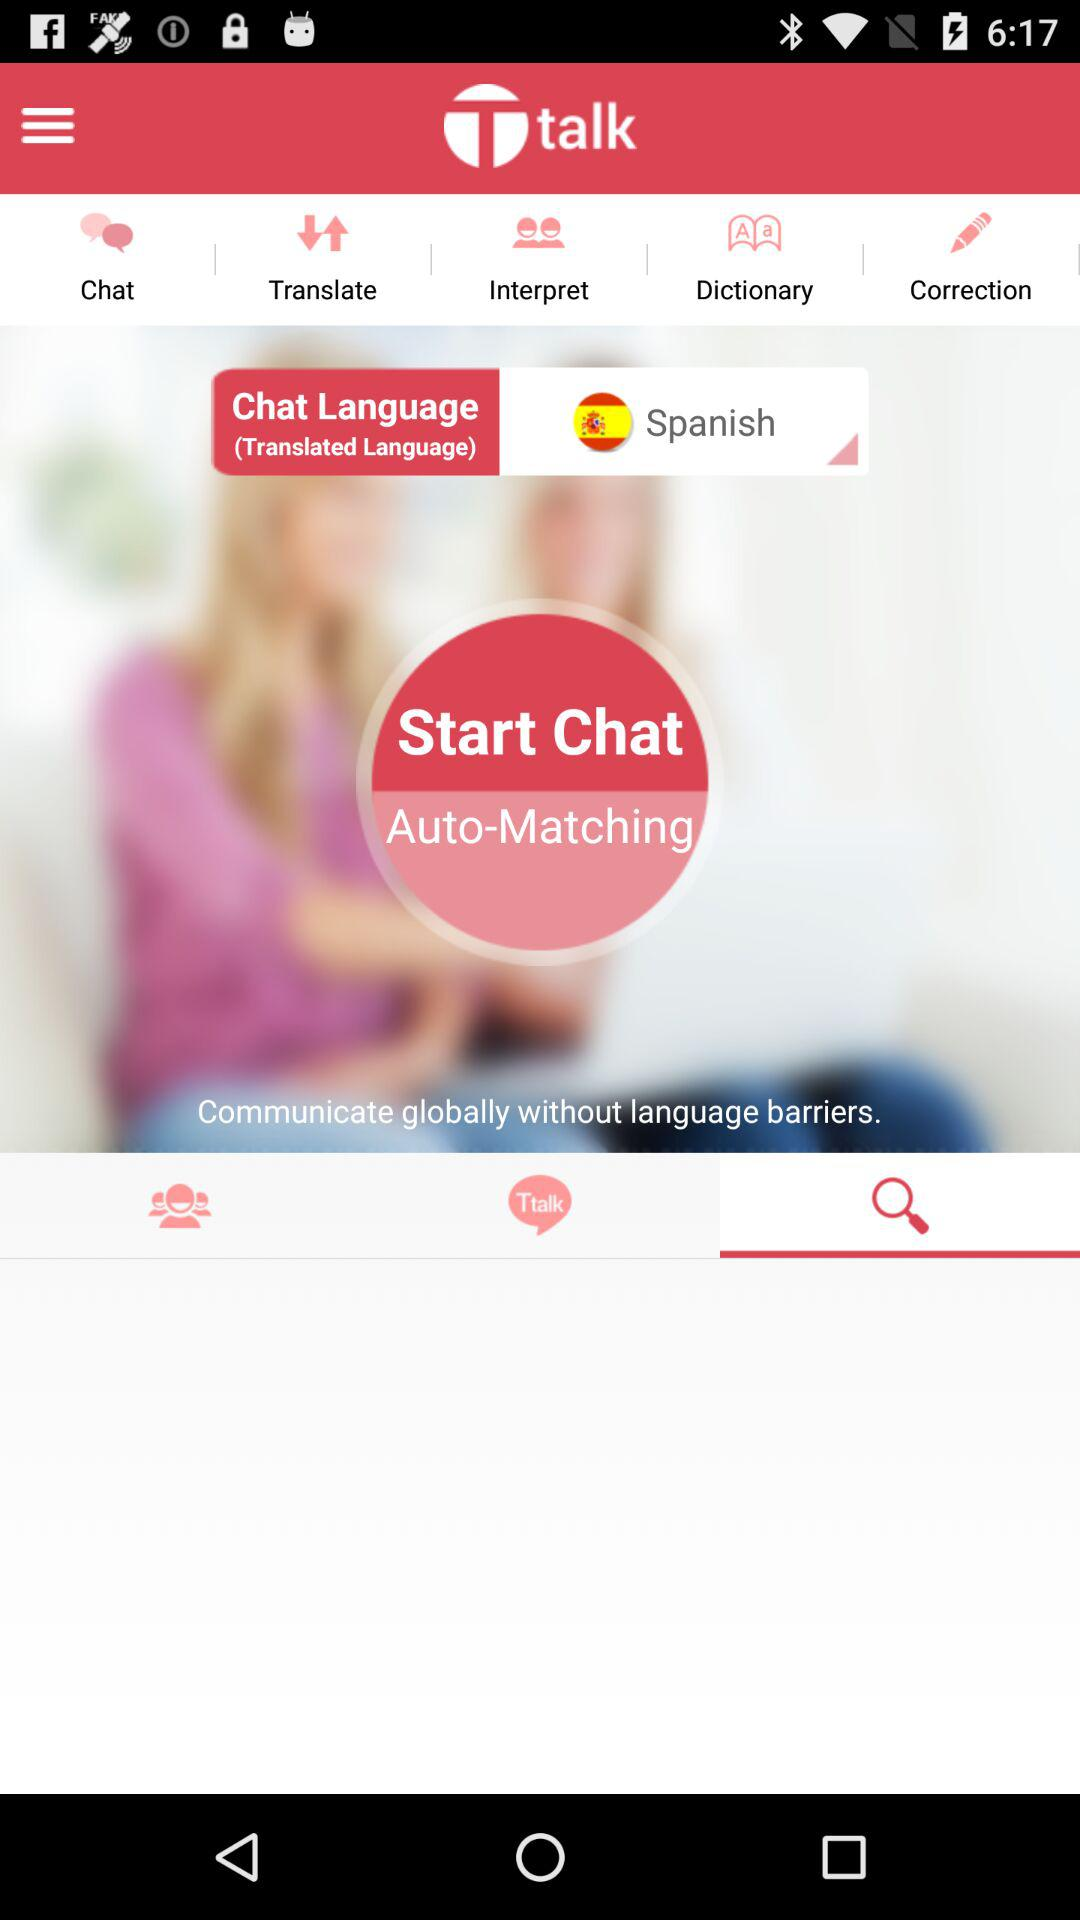What is the application name? The application name is "talk". 